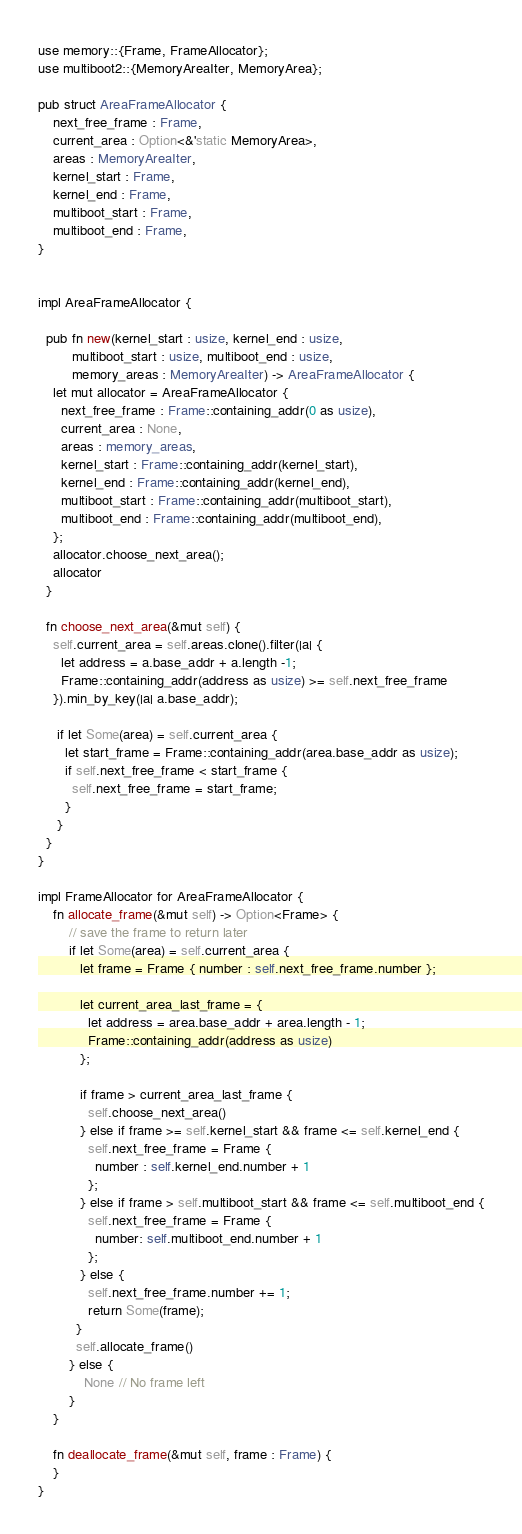<code> <loc_0><loc_0><loc_500><loc_500><_Rust_>use memory::{Frame, FrameAllocator};
use multiboot2::{MemoryAreaIter, MemoryArea};

pub struct AreaFrameAllocator {
    next_free_frame : Frame,
    current_area : Option<&'static MemoryArea>,
    areas : MemoryAreaIter,
    kernel_start : Frame,
    kernel_end : Frame,
    multiboot_start : Frame,
    multiboot_end : Frame,
}


impl AreaFrameAllocator {

  pub fn new(kernel_start : usize, kernel_end : usize,
         multiboot_start : usize, multiboot_end : usize,
         memory_areas : MemoryAreaIter) -> AreaFrameAllocator {
    let mut allocator = AreaFrameAllocator {
      next_free_frame : Frame::containing_addr(0 as usize),
      current_area : None,
      areas : memory_areas,
      kernel_start : Frame::containing_addr(kernel_start),
      kernel_end : Frame::containing_addr(kernel_end),
      multiboot_start : Frame::containing_addr(multiboot_start),
      multiboot_end : Frame::containing_addr(multiboot_end),
    };
    allocator.choose_next_area();
    allocator
  }

  fn choose_next_area(&mut self) {
    self.current_area = self.areas.clone().filter(|a| {
      let address = a.base_addr + a.length -1;
      Frame::containing_addr(address as usize) >= self.next_free_frame
    }).min_by_key(|a| a.base_addr);

     if let Some(area) = self.current_area {
       let start_frame = Frame::containing_addr(area.base_addr as usize);
       if self.next_free_frame < start_frame {
         self.next_free_frame = start_frame;
       }
     }
  }
}

impl FrameAllocator for AreaFrameAllocator {
    fn allocate_frame(&mut self) -> Option<Frame> {
        // save the frame to return later
        if let Some(area) = self.current_area {
           let frame = Frame { number : self.next_free_frame.number };

           let current_area_last_frame = {
             let address = area.base_addr + area.length - 1;
             Frame::containing_addr(address as usize)
           };

           if frame > current_area_last_frame {
             self.choose_next_area()
           } else if frame >= self.kernel_start && frame <= self.kernel_end {
             self.next_free_frame = Frame {
               number : self.kernel_end.number + 1
             };
           } else if frame > self.multiboot_start && frame <= self.multiboot_end {
             self.next_free_frame = Frame {
               number: self.multiboot_end.number + 1
             };
           } else {
             self.next_free_frame.number += 1;
             return Some(frame);
          }
          self.allocate_frame()
        } else {
            None // No frame left
        }
    }

    fn deallocate_frame(&mut self, frame : Frame) {
    }
}
</code> 